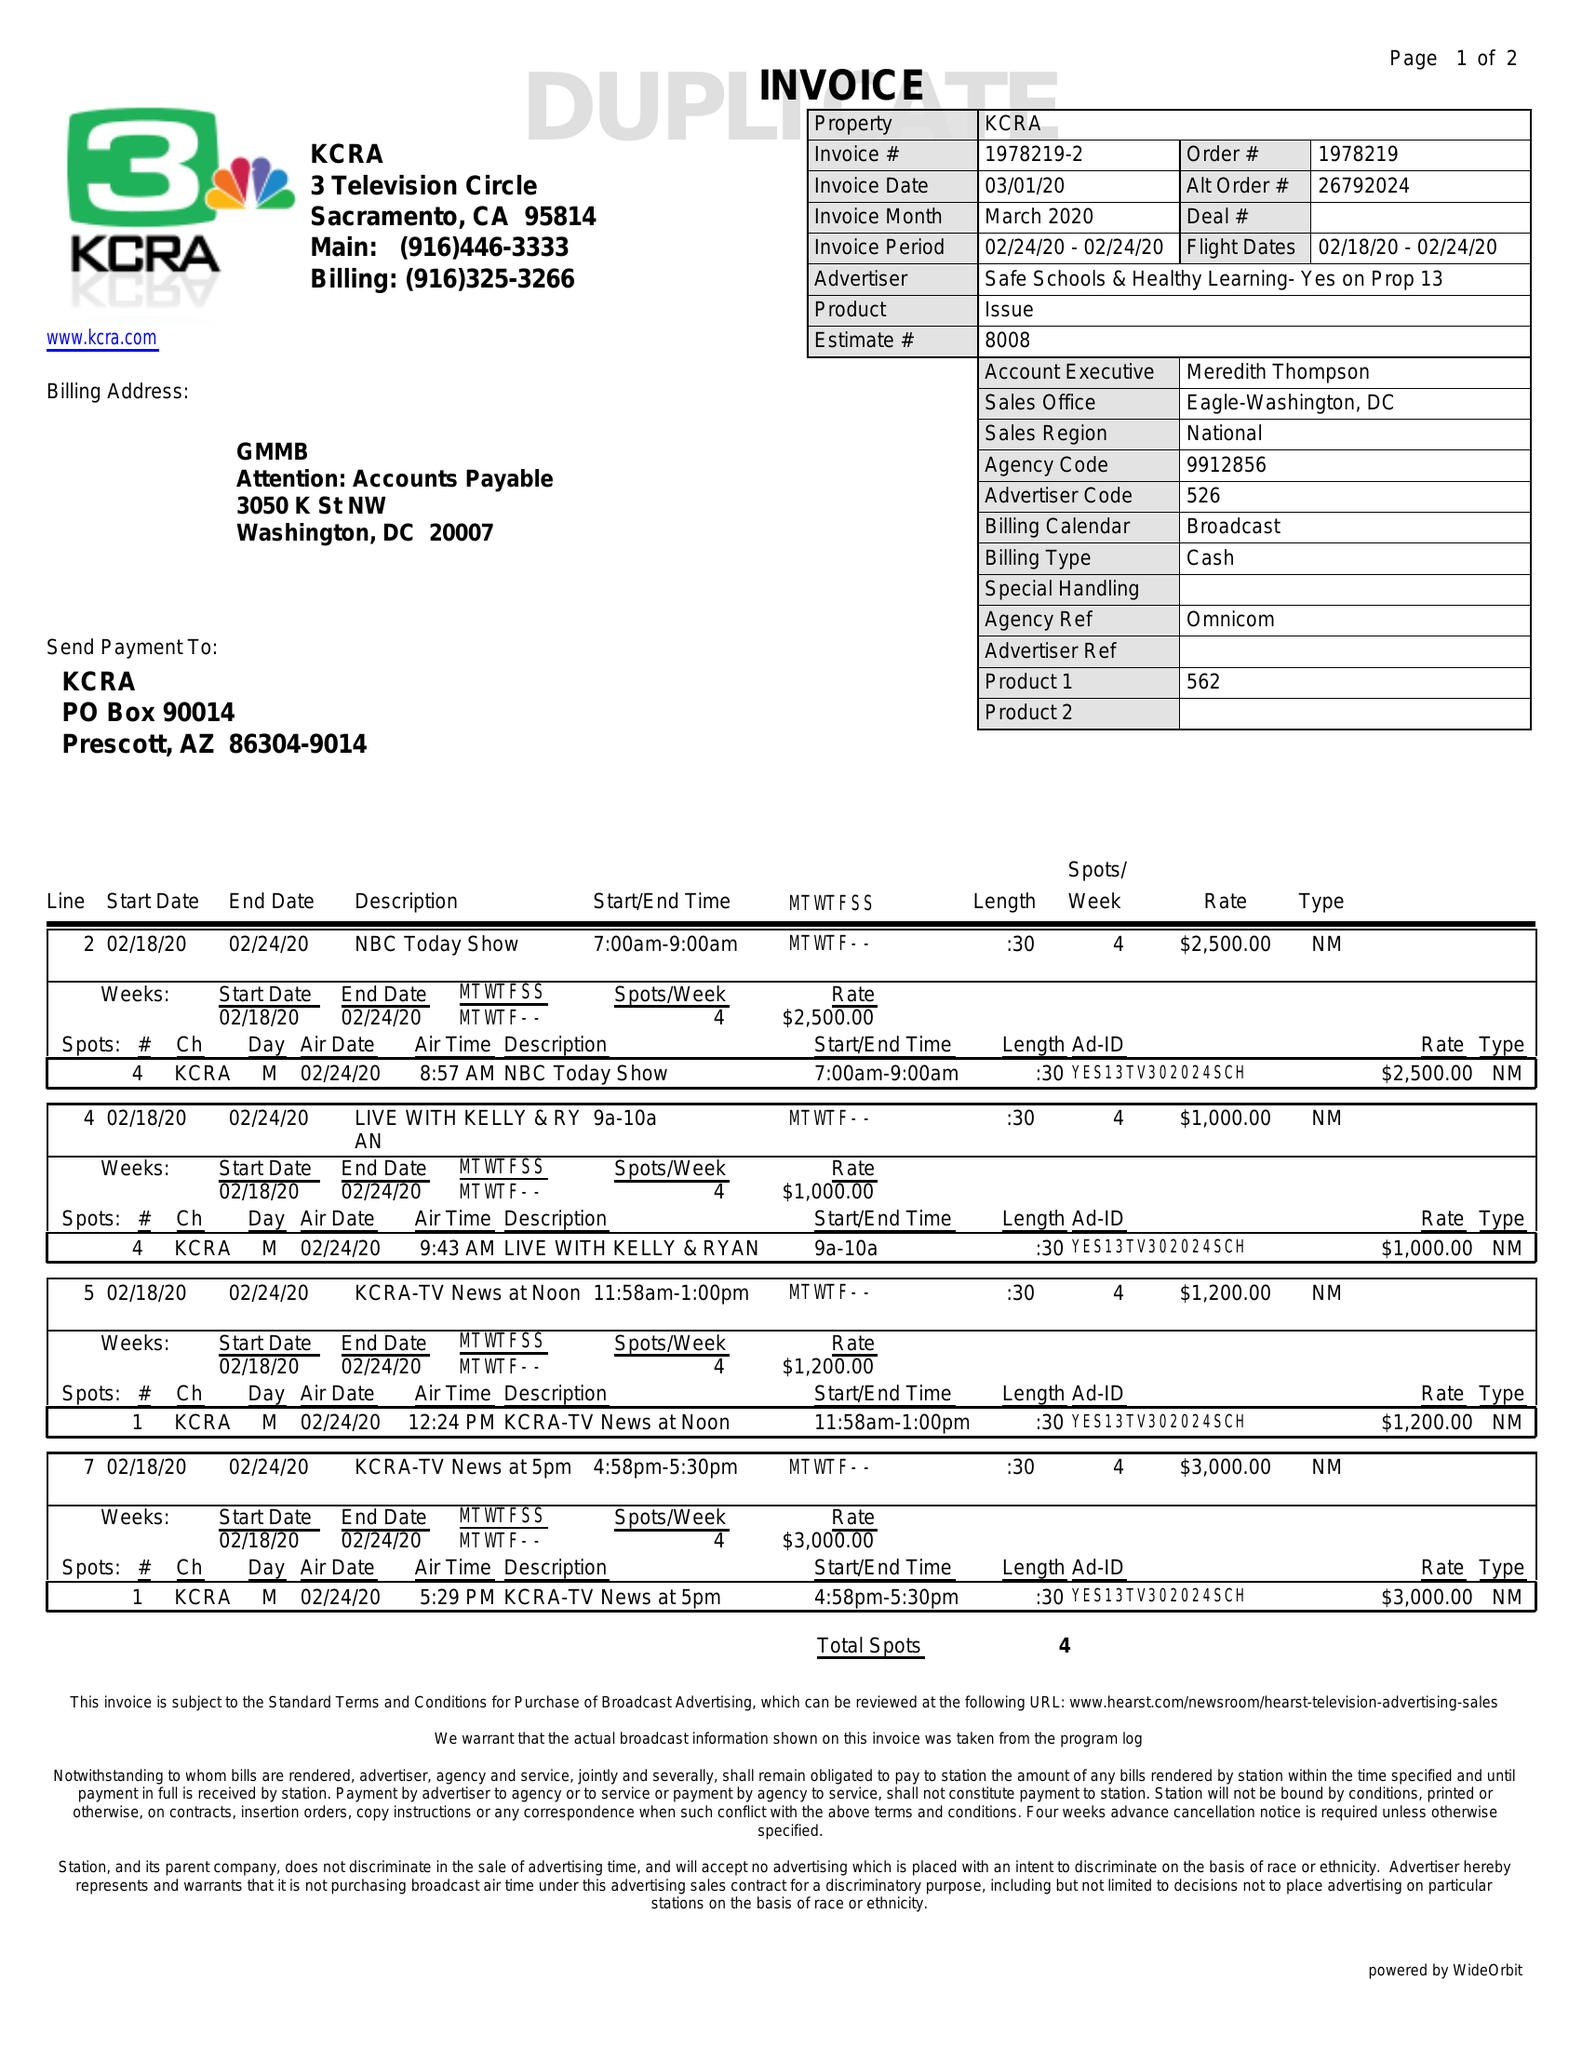What is the value for the advertiser?
Answer the question using a single word or phrase. SAFE SCHOOLS & HEALTHY LEARNING- YES ON PROP 13 